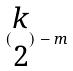Convert formula to latex. <formula><loc_0><loc_0><loc_500><loc_500>( \begin{matrix} k \\ 2 \end{matrix} ) - m</formula> 